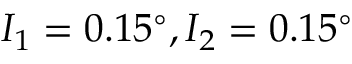Convert formula to latex. <formula><loc_0><loc_0><loc_500><loc_500>I _ { 1 } = 0 . 1 5 ^ { \circ } , I _ { 2 } = 0 . 1 5 ^ { \circ }</formula> 